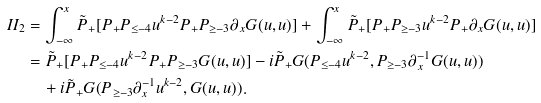Convert formula to latex. <formula><loc_0><loc_0><loc_500><loc_500>I I _ { 2 } & = \int _ { - \infty } ^ { x } \tilde { P } _ { + } [ P _ { + } P _ { \leq - 4 } u ^ { k - 2 } P _ { + } P _ { \geq - 3 } \partial _ { x } G ( u , u ) ] + \int _ { - \infty } ^ { x } \tilde { P } _ { + } [ P _ { + } P _ { \geq - 3 } u ^ { k - 2 } P _ { + } \partial _ { x } G ( u , u ) ] \\ & = \tilde { P } _ { + } [ P _ { + } P _ { \leq - 4 } u ^ { k - 2 } P _ { + } P _ { \geq - 3 } G ( u , u ) ] - i \tilde { P } _ { + } G ( P _ { \leq - 4 } u ^ { k - 2 } , P _ { \geq - 3 } \partial _ { x } ^ { - 1 } G ( u , u ) ) \\ & \quad + i \tilde { P } _ { + } G ( P _ { \geq - 3 } \partial _ { x } ^ { - 1 } u ^ { k - 2 } , G ( u , u ) ) .</formula> 